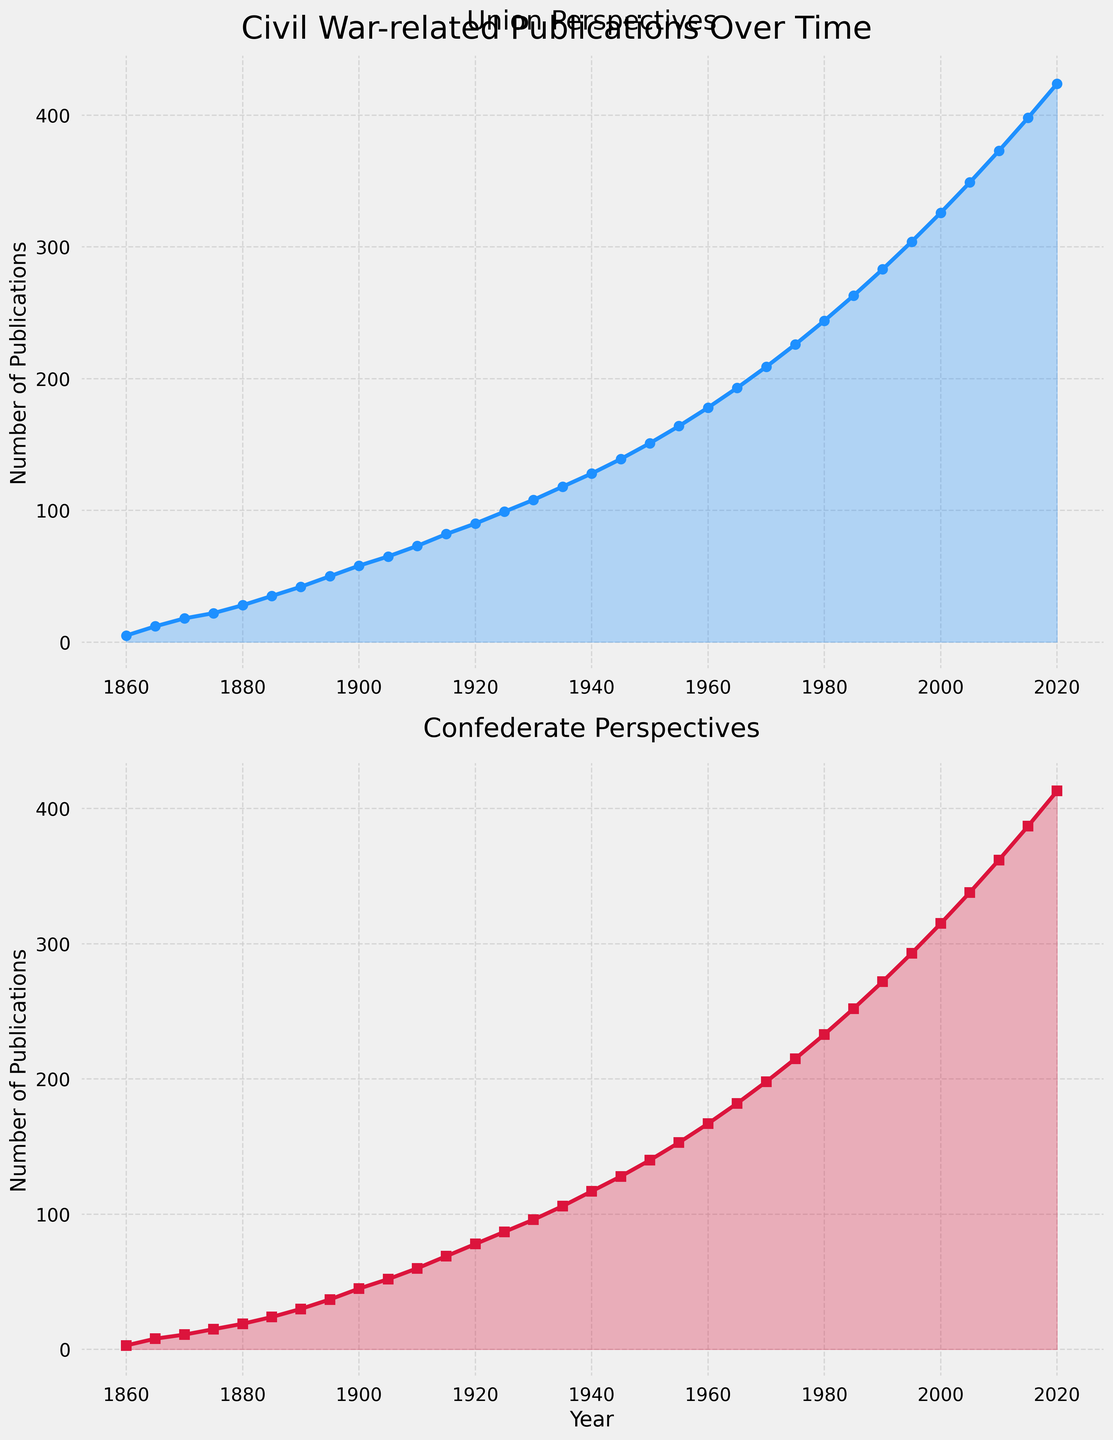What is the overall trend for Union perspectives publications from 1860 to 2020? The Union perspectives show a consistent upward trend in the number of publications over the years, indicating increasing interest or documentation in this perspective. This can be visually confirmed by the continuous rise of the blue line in the top subplot.
Answer: Consistent upward trend Which decade saw the highest increase in Confederate perspectives publications? By examining the red line in the bottom subplot, the largest increase in Confederate publications appears between 1970 and 1980, where the number rises from 198 to 233, an increase of 35 publications.
Answer: 1970 to 1980 By how much did the number of Union perspectives publications outnumber Confederate perspectives publications in 1920? In 1920, the number of Union perspectives publications is 90, and Confederate perspectives publications are 78. The difference is 90 - 78 = 12.
Answer: 12 Which year did Union perspectives publications reach 100? By observing the blue line in the top subplot, Union perspectives publications crossed 100 around the year 1925 where we see the point marked on the chart.
Answer: 1925 Compare the growth rates of Union and Confederate perspectives from 1865 to 1885. Which is faster and by how much? Union perspectives grow from 12 in 1865 to 35 in 1885, an increase of 23 publications. Confederate perspectives grow from 8 in 1865 to 24 in 1885, an increase of 16 publications. The difference in growth rates is 23 - 16 = 7.
Answer: Union perspectives by 7 publications Which perspective had more publications in 1985, and by what margin? In 1985, Union perspectives publications stand at 263, while Confederate perspectives publications are 252. The margin is 263 - 252 = 11.
Answer: Union perspectives by 11 What is the average number of publications for Confederate perspectives from 1860 to 1900? Summing the values for Confederate perspectives from 1860 (3) to 1900 (45), we get 3 + 8 + 11 + 15 + 19 + 24 + 30 + 37 + 45 = 192. There are 9 points, so the average is 192 / 9 ≈ 21.33.
Answer: 21.33 What are the publication counts for Union and Confederate perspectives in 1945, and what is their sum? In 1945, Union perspectives publications are 139 and Confederate perspectives publications are 128. The sum is 139 + 128 = 267.
Answer: 267 How does the steepness of the lines differ between Union and Confederate perspectives around the 1960s? The rate of increase for Union perspectives (blue line) seems steeper compared to the Confederate perspectives (red line) around the 1960s, indicating a faster growth rate for Union publications during this period.
Answer: Union had a steeper increase 